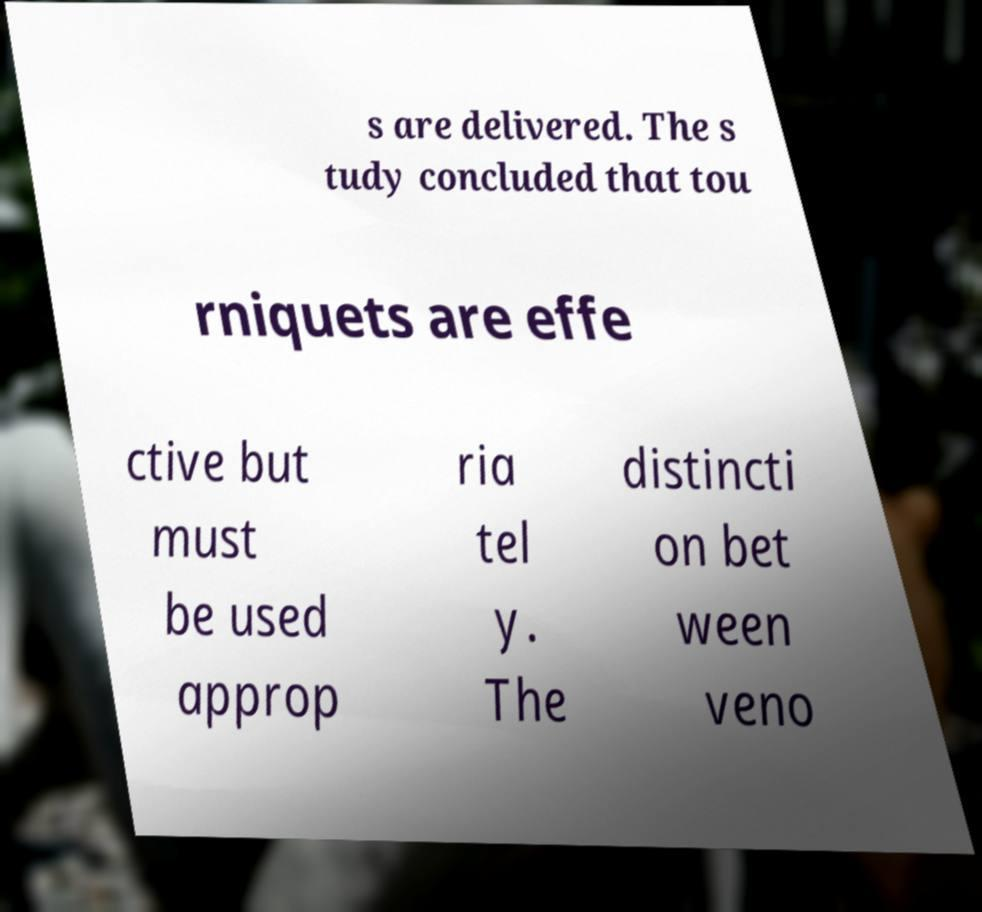What messages or text are displayed in this image? I need them in a readable, typed format. s are delivered. The s tudy concluded that tou rniquets are effe ctive but must be used approp ria tel y. The distincti on bet ween veno 